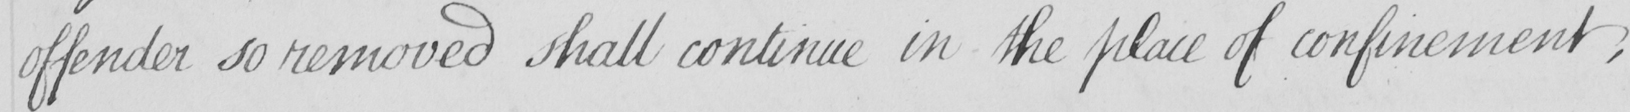Please provide the text content of this handwritten line. offender so removed shall continue in the place of confinement , 